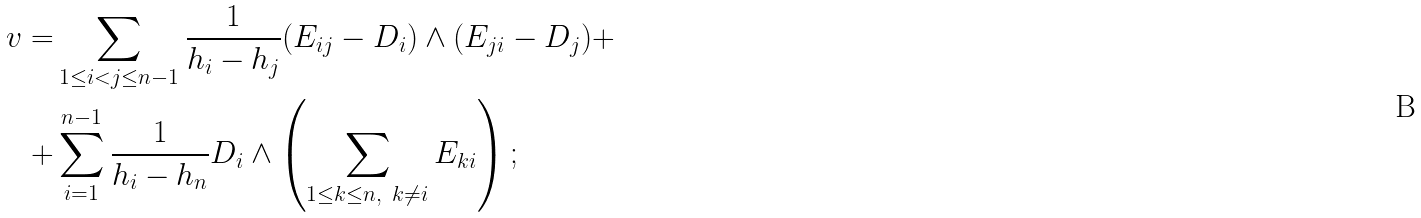<formula> <loc_0><loc_0><loc_500><loc_500>v = & \sum _ { 1 \leq i < j \leq n - 1 } \frac { 1 } { h _ { i } - h _ { j } } ( E _ { i j } - D _ { i } ) \wedge ( E _ { j i } - D _ { j } ) + \\ + & \sum _ { i = 1 } ^ { n - 1 } \frac { 1 } { h _ { i } - h _ { n } } D _ { i } \wedge \left ( \sum _ { 1 \leq k \leq n , \ k \neq i } E _ { k i } \right ) ;</formula> 